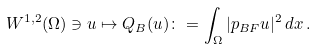Convert formula to latex. <formula><loc_0><loc_0><loc_500><loc_500>W ^ { 1 , 2 } ( \Omega ) \ni u \mapsto Q _ { B } ( u ) \colon = \int _ { \Omega } | p _ { B { F } } u | ^ { 2 } \, d x \, .</formula> 